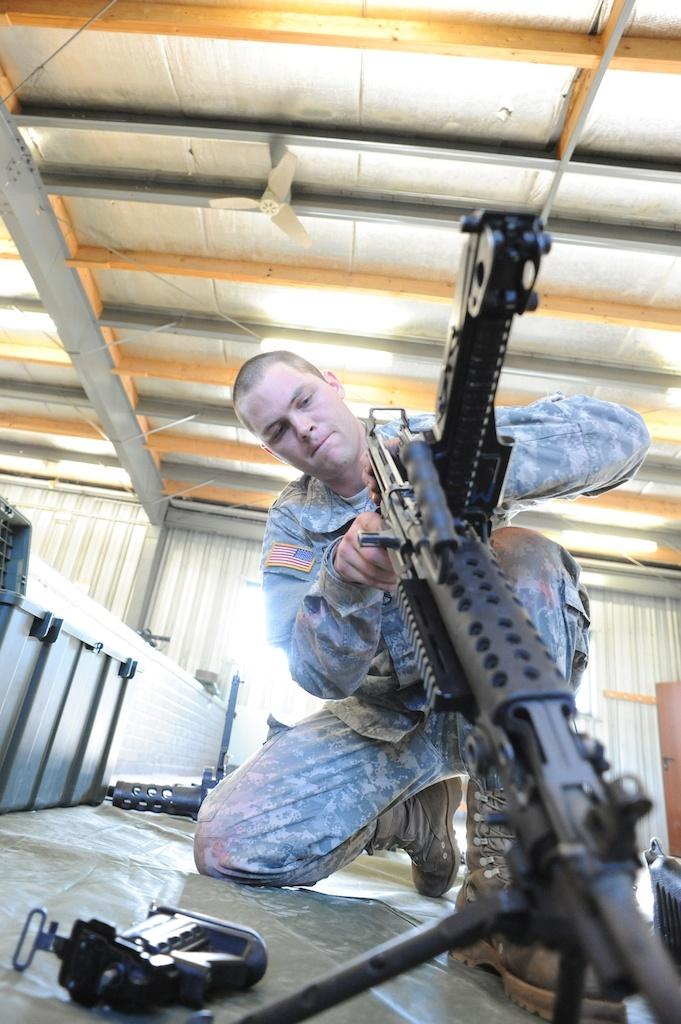What is the person in the image wearing? The person in the image is wearing military dress. What is the person holding in the image? The person is holding a weapon. Are there any other weapons visible in the image? Yes, there are additional weapons on the floor. Where is the person located in the image? The person is inside a shed. What type of cow can be seen in the image? There is no cow present in the image. How many fingers does the person have on their left hand in the image? The image does not show the person's fingers, so it cannot be determined how many fingers they have on their left hand. 